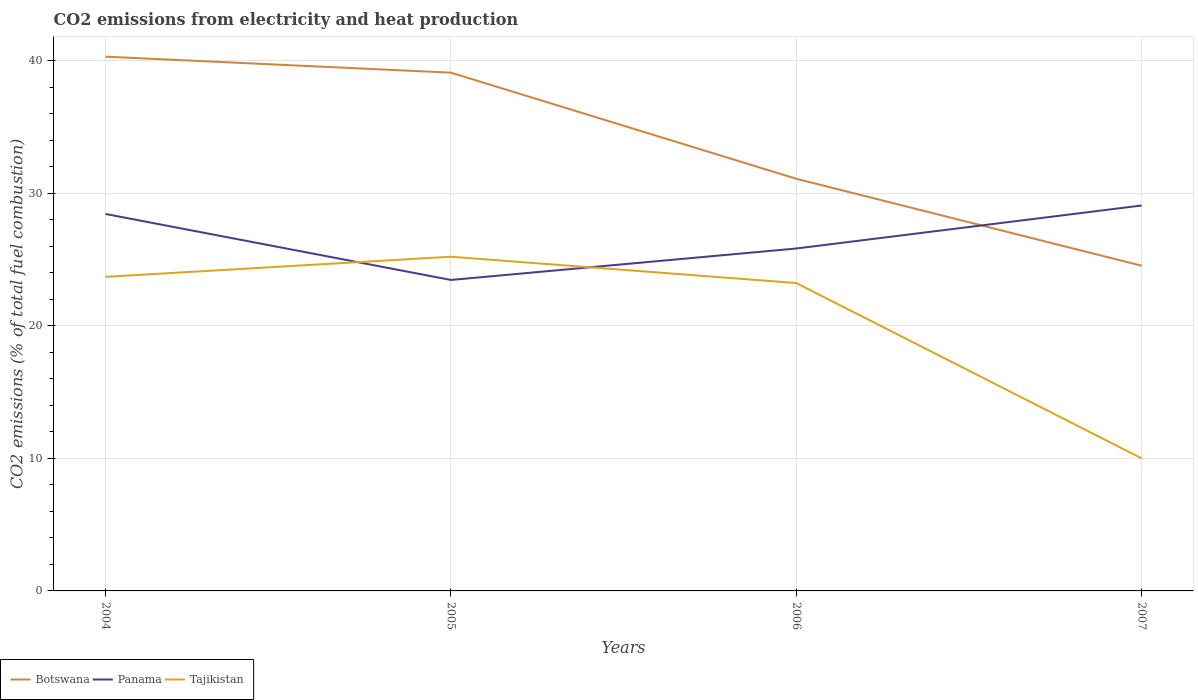How many different coloured lines are there?
Offer a terse response. 3. Is the number of lines equal to the number of legend labels?
Offer a very short reply. Yes. Across all years, what is the maximum amount of CO2 emitted in Panama?
Your answer should be very brief. 23.46. What is the total amount of CO2 emitted in Panama in the graph?
Your answer should be very brief. -5.62. What is the difference between the highest and the second highest amount of CO2 emitted in Panama?
Your answer should be very brief. 5.62. What is the difference between the highest and the lowest amount of CO2 emitted in Tajikistan?
Make the answer very short. 3. How many years are there in the graph?
Offer a very short reply. 4. What is the difference between two consecutive major ticks on the Y-axis?
Your response must be concise. 10. Does the graph contain any zero values?
Offer a very short reply. No. Where does the legend appear in the graph?
Your response must be concise. Bottom left. How many legend labels are there?
Offer a terse response. 3. How are the legend labels stacked?
Your response must be concise. Horizontal. What is the title of the graph?
Make the answer very short. CO2 emissions from electricity and heat production. Does "Denmark" appear as one of the legend labels in the graph?
Your response must be concise. No. What is the label or title of the Y-axis?
Offer a terse response. CO2 emissions (% of total fuel combustion). What is the CO2 emissions (% of total fuel combustion) of Botswana in 2004?
Make the answer very short. 40.31. What is the CO2 emissions (% of total fuel combustion) in Panama in 2004?
Provide a succinct answer. 28.44. What is the CO2 emissions (% of total fuel combustion) of Tajikistan in 2004?
Offer a terse response. 23.69. What is the CO2 emissions (% of total fuel combustion) of Botswana in 2005?
Offer a very short reply. 39.1. What is the CO2 emissions (% of total fuel combustion) in Panama in 2005?
Your answer should be very brief. 23.46. What is the CO2 emissions (% of total fuel combustion) of Tajikistan in 2005?
Your answer should be very brief. 25.21. What is the CO2 emissions (% of total fuel combustion) in Botswana in 2006?
Provide a short and direct response. 31.09. What is the CO2 emissions (% of total fuel combustion) in Panama in 2006?
Your answer should be very brief. 25.83. What is the CO2 emissions (% of total fuel combustion) of Tajikistan in 2006?
Offer a very short reply. 23.23. What is the CO2 emissions (% of total fuel combustion) in Botswana in 2007?
Your answer should be very brief. 24.53. What is the CO2 emissions (% of total fuel combustion) in Panama in 2007?
Keep it short and to the point. 29.08. What is the CO2 emissions (% of total fuel combustion) of Tajikistan in 2007?
Give a very brief answer. 10. Across all years, what is the maximum CO2 emissions (% of total fuel combustion) in Botswana?
Offer a terse response. 40.31. Across all years, what is the maximum CO2 emissions (% of total fuel combustion) in Panama?
Keep it short and to the point. 29.08. Across all years, what is the maximum CO2 emissions (% of total fuel combustion) in Tajikistan?
Provide a succinct answer. 25.21. Across all years, what is the minimum CO2 emissions (% of total fuel combustion) in Botswana?
Offer a terse response. 24.53. Across all years, what is the minimum CO2 emissions (% of total fuel combustion) in Panama?
Provide a succinct answer. 23.46. What is the total CO2 emissions (% of total fuel combustion) of Botswana in the graph?
Provide a succinct answer. 135.03. What is the total CO2 emissions (% of total fuel combustion) in Panama in the graph?
Offer a very short reply. 106.81. What is the total CO2 emissions (% of total fuel combustion) in Tajikistan in the graph?
Offer a terse response. 82.14. What is the difference between the CO2 emissions (% of total fuel combustion) in Botswana in 2004 and that in 2005?
Keep it short and to the point. 1.21. What is the difference between the CO2 emissions (% of total fuel combustion) of Panama in 2004 and that in 2005?
Make the answer very short. 4.98. What is the difference between the CO2 emissions (% of total fuel combustion) of Tajikistan in 2004 and that in 2005?
Offer a terse response. -1.52. What is the difference between the CO2 emissions (% of total fuel combustion) in Botswana in 2004 and that in 2006?
Your response must be concise. 9.21. What is the difference between the CO2 emissions (% of total fuel combustion) in Panama in 2004 and that in 2006?
Your answer should be very brief. 2.61. What is the difference between the CO2 emissions (% of total fuel combustion) in Tajikistan in 2004 and that in 2006?
Provide a succinct answer. 0.47. What is the difference between the CO2 emissions (% of total fuel combustion) of Botswana in 2004 and that in 2007?
Keep it short and to the point. 15.77. What is the difference between the CO2 emissions (% of total fuel combustion) in Panama in 2004 and that in 2007?
Make the answer very short. -0.64. What is the difference between the CO2 emissions (% of total fuel combustion) in Tajikistan in 2004 and that in 2007?
Make the answer very short. 13.69. What is the difference between the CO2 emissions (% of total fuel combustion) of Botswana in 2005 and that in 2006?
Ensure brevity in your answer.  8.01. What is the difference between the CO2 emissions (% of total fuel combustion) in Panama in 2005 and that in 2006?
Ensure brevity in your answer.  -2.37. What is the difference between the CO2 emissions (% of total fuel combustion) in Tajikistan in 2005 and that in 2006?
Provide a short and direct response. 1.99. What is the difference between the CO2 emissions (% of total fuel combustion) in Botswana in 2005 and that in 2007?
Your answer should be very brief. 14.57. What is the difference between the CO2 emissions (% of total fuel combustion) in Panama in 2005 and that in 2007?
Ensure brevity in your answer.  -5.62. What is the difference between the CO2 emissions (% of total fuel combustion) of Tajikistan in 2005 and that in 2007?
Your response must be concise. 15.21. What is the difference between the CO2 emissions (% of total fuel combustion) of Botswana in 2006 and that in 2007?
Make the answer very short. 6.56. What is the difference between the CO2 emissions (% of total fuel combustion) of Panama in 2006 and that in 2007?
Your answer should be very brief. -3.24. What is the difference between the CO2 emissions (% of total fuel combustion) in Tajikistan in 2006 and that in 2007?
Provide a short and direct response. 13.23. What is the difference between the CO2 emissions (% of total fuel combustion) of Botswana in 2004 and the CO2 emissions (% of total fuel combustion) of Panama in 2005?
Ensure brevity in your answer.  16.85. What is the difference between the CO2 emissions (% of total fuel combustion) in Botswana in 2004 and the CO2 emissions (% of total fuel combustion) in Tajikistan in 2005?
Offer a very short reply. 15.09. What is the difference between the CO2 emissions (% of total fuel combustion) of Panama in 2004 and the CO2 emissions (% of total fuel combustion) of Tajikistan in 2005?
Ensure brevity in your answer.  3.23. What is the difference between the CO2 emissions (% of total fuel combustion) in Botswana in 2004 and the CO2 emissions (% of total fuel combustion) in Panama in 2006?
Offer a terse response. 14.47. What is the difference between the CO2 emissions (% of total fuel combustion) of Botswana in 2004 and the CO2 emissions (% of total fuel combustion) of Tajikistan in 2006?
Make the answer very short. 17.08. What is the difference between the CO2 emissions (% of total fuel combustion) of Panama in 2004 and the CO2 emissions (% of total fuel combustion) of Tajikistan in 2006?
Offer a terse response. 5.21. What is the difference between the CO2 emissions (% of total fuel combustion) in Botswana in 2004 and the CO2 emissions (% of total fuel combustion) in Panama in 2007?
Your response must be concise. 11.23. What is the difference between the CO2 emissions (% of total fuel combustion) in Botswana in 2004 and the CO2 emissions (% of total fuel combustion) in Tajikistan in 2007?
Ensure brevity in your answer.  30.31. What is the difference between the CO2 emissions (% of total fuel combustion) of Panama in 2004 and the CO2 emissions (% of total fuel combustion) of Tajikistan in 2007?
Your answer should be compact. 18.44. What is the difference between the CO2 emissions (% of total fuel combustion) of Botswana in 2005 and the CO2 emissions (% of total fuel combustion) of Panama in 2006?
Ensure brevity in your answer.  13.27. What is the difference between the CO2 emissions (% of total fuel combustion) of Botswana in 2005 and the CO2 emissions (% of total fuel combustion) of Tajikistan in 2006?
Your answer should be compact. 15.87. What is the difference between the CO2 emissions (% of total fuel combustion) in Panama in 2005 and the CO2 emissions (% of total fuel combustion) in Tajikistan in 2006?
Provide a succinct answer. 0.23. What is the difference between the CO2 emissions (% of total fuel combustion) in Botswana in 2005 and the CO2 emissions (% of total fuel combustion) in Panama in 2007?
Ensure brevity in your answer.  10.02. What is the difference between the CO2 emissions (% of total fuel combustion) of Botswana in 2005 and the CO2 emissions (% of total fuel combustion) of Tajikistan in 2007?
Make the answer very short. 29.1. What is the difference between the CO2 emissions (% of total fuel combustion) in Panama in 2005 and the CO2 emissions (% of total fuel combustion) in Tajikistan in 2007?
Keep it short and to the point. 13.46. What is the difference between the CO2 emissions (% of total fuel combustion) in Botswana in 2006 and the CO2 emissions (% of total fuel combustion) in Panama in 2007?
Make the answer very short. 2.02. What is the difference between the CO2 emissions (% of total fuel combustion) of Botswana in 2006 and the CO2 emissions (% of total fuel combustion) of Tajikistan in 2007?
Your response must be concise. 21.09. What is the difference between the CO2 emissions (% of total fuel combustion) in Panama in 2006 and the CO2 emissions (% of total fuel combustion) in Tajikistan in 2007?
Offer a terse response. 15.83. What is the average CO2 emissions (% of total fuel combustion) of Botswana per year?
Give a very brief answer. 33.76. What is the average CO2 emissions (% of total fuel combustion) of Panama per year?
Your answer should be compact. 26.7. What is the average CO2 emissions (% of total fuel combustion) in Tajikistan per year?
Offer a terse response. 20.53. In the year 2004, what is the difference between the CO2 emissions (% of total fuel combustion) in Botswana and CO2 emissions (% of total fuel combustion) in Panama?
Ensure brevity in your answer.  11.87. In the year 2004, what is the difference between the CO2 emissions (% of total fuel combustion) of Botswana and CO2 emissions (% of total fuel combustion) of Tajikistan?
Provide a succinct answer. 16.61. In the year 2004, what is the difference between the CO2 emissions (% of total fuel combustion) of Panama and CO2 emissions (% of total fuel combustion) of Tajikistan?
Offer a very short reply. 4.74. In the year 2005, what is the difference between the CO2 emissions (% of total fuel combustion) in Botswana and CO2 emissions (% of total fuel combustion) in Panama?
Keep it short and to the point. 15.64. In the year 2005, what is the difference between the CO2 emissions (% of total fuel combustion) in Botswana and CO2 emissions (% of total fuel combustion) in Tajikistan?
Offer a terse response. 13.89. In the year 2005, what is the difference between the CO2 emissions (% of total fuel combustion) in Panama and CO2 emissions (% of total fuel combustion) in Tajikistan?
Ensure brevity in your answer.  -1.75. In the year 2006, what is the difference between the CO2 emissions (% of total fuel combustion) of Botswana and CO2 emissions (% of total fuel combustion) of Panama?
Provide a succinct answer. 5.26. In the year 2006, what is the difference between the CO2 emissions (% of total fuel combustion) in Botswana and CO2 emissions (% of total fuel combustion) in Tajikistan?
Make the answer very short. 7.87. In the year 2006, what is the difference between the CO2 emissions (% of total fuel combustion) of Panama and CO2 emissions (% of total fuel combustion) of Tajikistan?
Ensure brevity in your answer.  2.6. In the year 2007, what is the difference between the CO2 emissions (% of total fuel combustion) of Botswana and CO2 emissions (% of total fuel combustion) of Panama?
Your answer should be very brief. -4.55. In the year 2007, what is the difference between the CO2 emissions (% of total fuel combustion) in Botswana and CO2 emissions (% of total fuel combustion) in Tajikistan?
Provide a short and direct response. 14.53. In the year 2007, what is the difference between the CO2 emissions (% of total fuel combustion) of Panama and CO2 emissions (% of total fuel combustion) of Tajikistan?
Provide a short and direct response. 19.08. What is the ratio of the CO2 emissions (% of total fuel combustion) in Botswana in 2004 to that in 2005?
Give a very brief answer. 1.03. What is the ratio of the CO2 emissions (% of total fuel combustion) of Panama in 2004 to that in 2005?
Ensure brevity in your answer.  1.21. What is the ratio of the CO2 emissions (% of total fuel combustion) in Tajikistan in 2004 to that in 2005?
Provide a succinct answer. 0.94. What is the ratio of the CO2 emissions (% of total fuel combustion) of Botswana in 2004 to that in 2006?
Keep it short and to the point. 1.3. What is the ratio of the CO2 emissions (% of total fuel combustion) in Panama in 2004 to that in 2006?
Offer a terse response. 1.1. What is the ratio of the CO2 emissions (% of total fuel combustion) of Tajikistan in 2004 to that in 2006?
Make the answer very short. 1.02. What is the ratio of the CO2 emissions (% of total fuel combustion) of Botswana in 2004 to that in 2007?
Ensure brevity in your answer.  1.64. What is the ratio of the CO2 emissions (% of total fuel combustion) in Tajikistan in 2004 to that in 2007?
Provide a succinct answer. 2.37. What is the ratio of the CO2 emissions (% of total fuel combustion) in Botswana in 2005 to that in 2006?
Offer a very short reply. 1.26. What is the ratio of the CO2 emissions (% of total fuel combustion) in Panama in 2005 to that in 2006?
Offer a very short reply. 0.91. What is the ratio of the CO2 emissions (% of total fuel combustion) in Tajikistan in 2005 to that in 2006?
Your answer should be compact. 1.09. What is the ratio of the CO2 emissions (% of total fuel combustion) of Botswana in 2005 to that in 2007?
Provide a succinct answer. 1.59. What is the ratio of the CO2 emissions (% of total fuel combustion) in Panama in 2005 to that in 2007?
Provide a succinct answer. 0.81. What is the ratio of the CO2 emissions (% of total fuel combustion) of Tajikistan in 2005 to that in 2007?
Your answer should be very brief. 2.52. What is the ratio of the CO2 emissions (% of total fuel combustion) in Botswana in 2006 to that in 2007?
Make the answer very short. 1.27. What is the ratio of the CO2 emissions (% of total fuel combustion) in Panama in 2006 to that in 2007?
Offer a terse response. 0.89. What is the ratio of the CO2 emissions (% of total fuel combustion) of Tajikistan in 2006 to that in 2007?
Offer a terse response. 2.32. What is the difference between the highest and the second highest CO2 emissions (% of total fuel combustion) of Botswana?
Keep it short and to the point. 1.21. What is the difference between the highest and the second highest CO2 emissions (% of total fuel combustion) in Panama?
Make the answer very short. 0.64. What is the difference between the highest and the second highest CO2 emissions (% of total fuel combustion) in Tajikistan?
Offer a terse response. 1.52. What is the difference between the highest and the lowest CO2 emissions (% of total fuel combustion) of Botswana?
Keep it short and to the point. 15.77. What is the difference between the highest and the lowest CO2 emissions (% of total fuel combustion) in Panama?
Your response must be concise. 5.62. What is the difference between the highest and the lowest CO2 emissions (% of total fuel combustion) in Tajikistan?
Your answer should be compact. 15.21. 